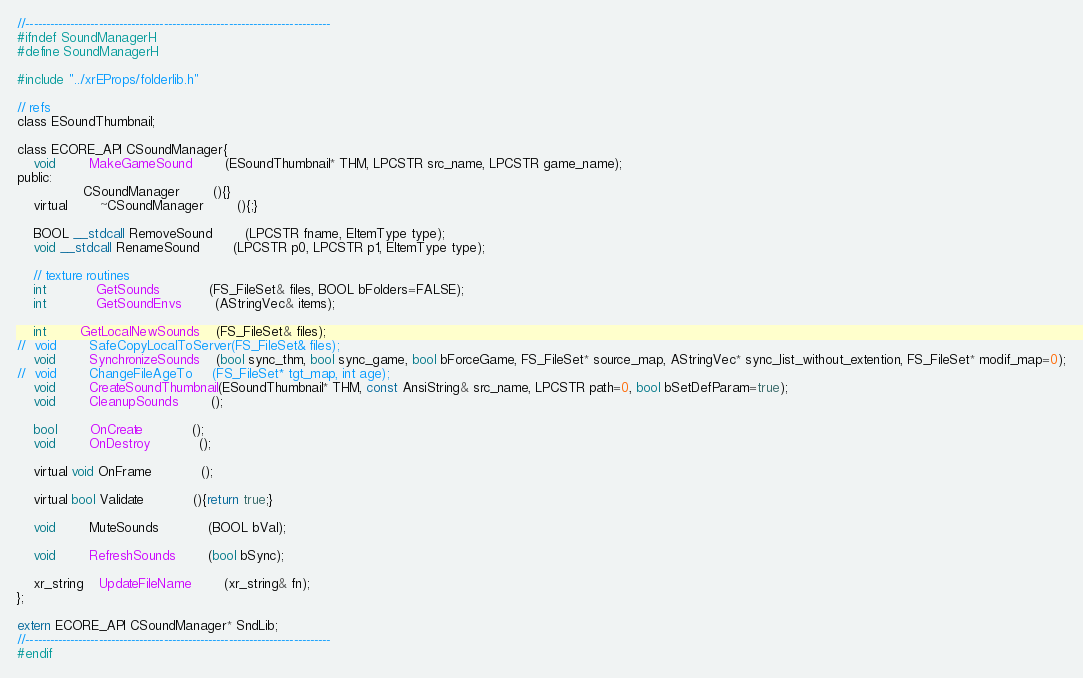Convert code to text. <code><loc_0><loc_0><loc_500><loc_500><_C_>//---------------------------------------------------------------------------
#ifndef SoundManagerH
#define SoundManagerH

#include "../xrEProps/folderlib.h"

// refs
class ESoundThumbnail;

class ECORE_API CSoundManager{
	void 		MakeGameSound		(ESoundThumbnail* THM, LPCSTR src_name, LPCSTR game_name);
public:
				CSoundManager		(){}
	virtual		~CSoundManager		(){;}
                    
    BOOL __stdcall RemoveSound		(LPCSTR fname, EItemType type);
	void __stdcall RenameSound		(LPCSTR p0, LPCSTR p1, EItemType type);

	// texture routines
    int			GetSounds			(FS_FileSet& files, BOOL bFolders=FALSE);
    int			GetSoundEnvs		(AStringVec& items);

	int 		GetLocalNewSounds	(FS_FileSet& files);
//	void		SafeCopyLocalToServer(FS_FileSet& files);
	void		SynchronizeSounds	(bool sync_thm, bool sync_game, bool bForceGame, FS_FileSet* source_map, AStringVec* sync_list_without_extention, FS_FileSet* modif_map=0);
//	void 		ChangeFileAgeTo		(FS_FileSet* tgt_map, int age);
    void		CreateSoundThumbnail(ESoundThumbnail* THM, const AnsiString& src_name, LPCSTR path=0, bool bSetDefParam=true);
	void		CleanupSounds		();

    bool		OnCreate			();
    void		OnDestroy			();

    virtual void OnFrame			();

    virtual bool Validate			(){return true;}

    void		MuteSounds			(BOOL bVal);

    void 		RefreshSounds		(bool bSync);

	xr_string	UpdateFileName		(xr_string& fn);
};

extern ECORE_API CSoundManager* SndLib;
//---------------------------------------------------------------------------
#endif
</code> 